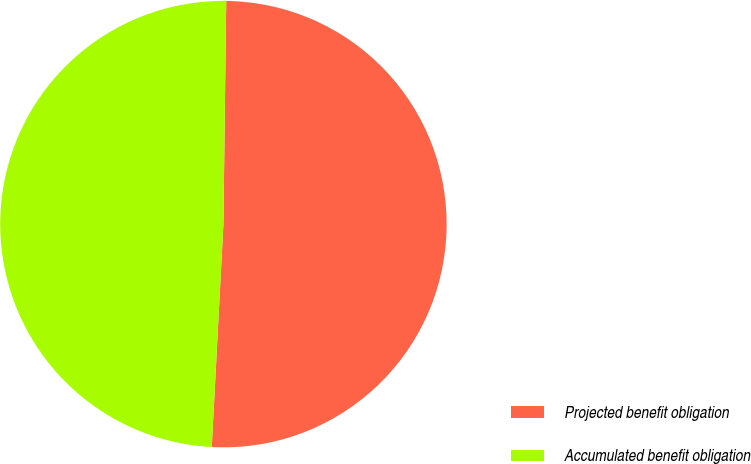Convert chart. <chart><loc_0><loc_0><loc_500><loc_500><pie_chart><fcel>Projected benefit obligation<fcel>Accumulated benefit obligation<nl><fcel>50.63%<fcel>49.37%<nl></chart> 